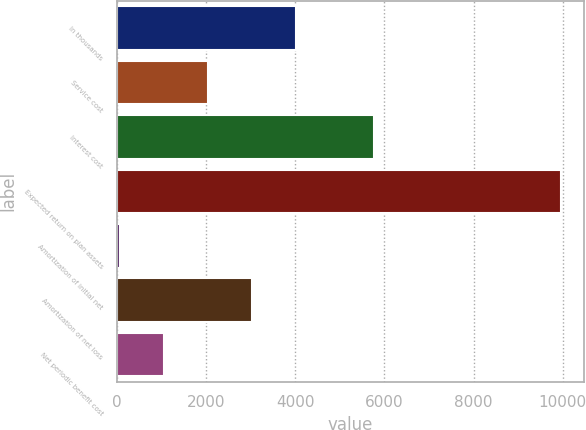<chart> <loc_0><loc_0><loc_500><loc_500><bar_chart><fcel>In thousands<fcel>Service cost<fcel>Interest cost<fcel>Expected return on plan assets<fcel>Amortization of initial net<fcel>Amortization of net loss<fcel>Net periodic benefit cost<nl><fcel>4025<fcel>2043<fcel>5774<fcel>9971<fcel>61<fcel>3034<fcel>1052<nl></chart> 